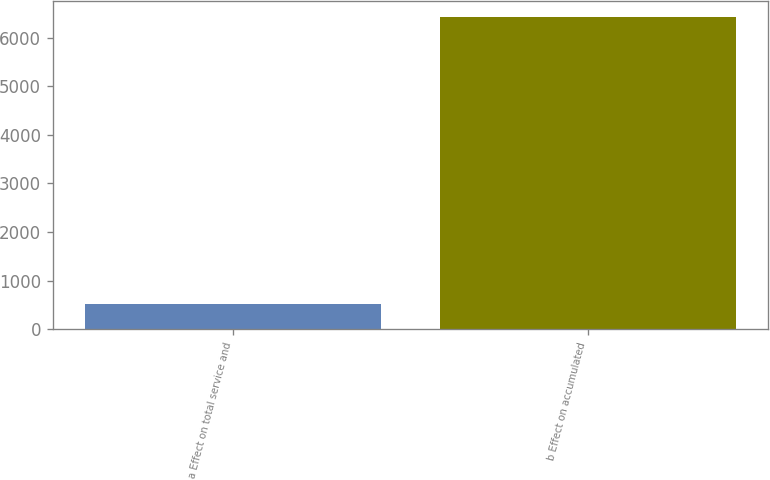Convert chart. <chart><loc_0><loc_0><loc_500><loc_500><bar_chart><fcel>a Effect on total service and<fcel>b Effect on accumulated<nl><fcel>518<fcel>6426<nl></chart> 